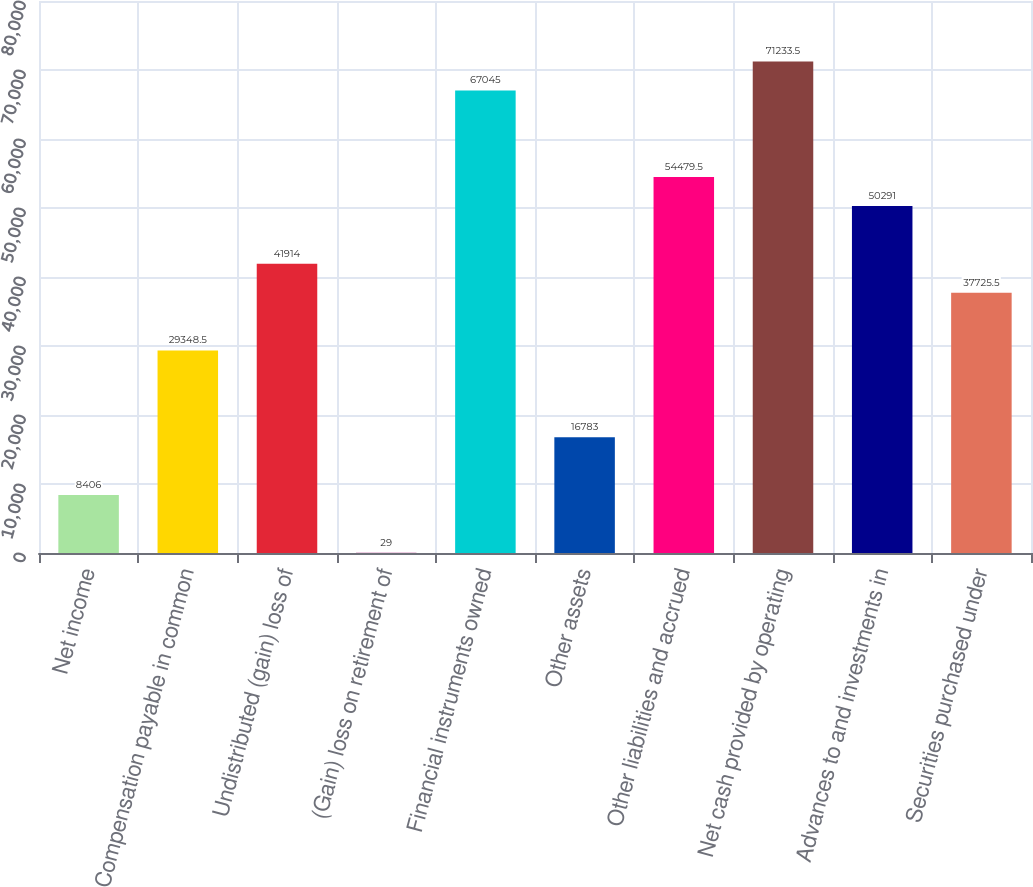Convert chart to OTSL. <chart><loc_0><loc_0><loc_500><loc_500><bar_chart><fcel>Net income<fcel>Compensation payable in common<fcel>Undistributed (gain) loss of<fcel>(Gain) loss on retirement of<fcel>Financial instruments owned<fcel>Other assets<fcel>Other liabilities and accrued<fcel>Net cash provided by operating<fcel>Advances to and investments in<fcel>Securities purchased under<nl><fcel>8406<fcel>29348.5<fcel>41914<fcel>29<fcel>67045<fcel>16783<fcel>54479.5<fcel>71233.5<fcel>50291<fcel>37725.5<nl></chart> 